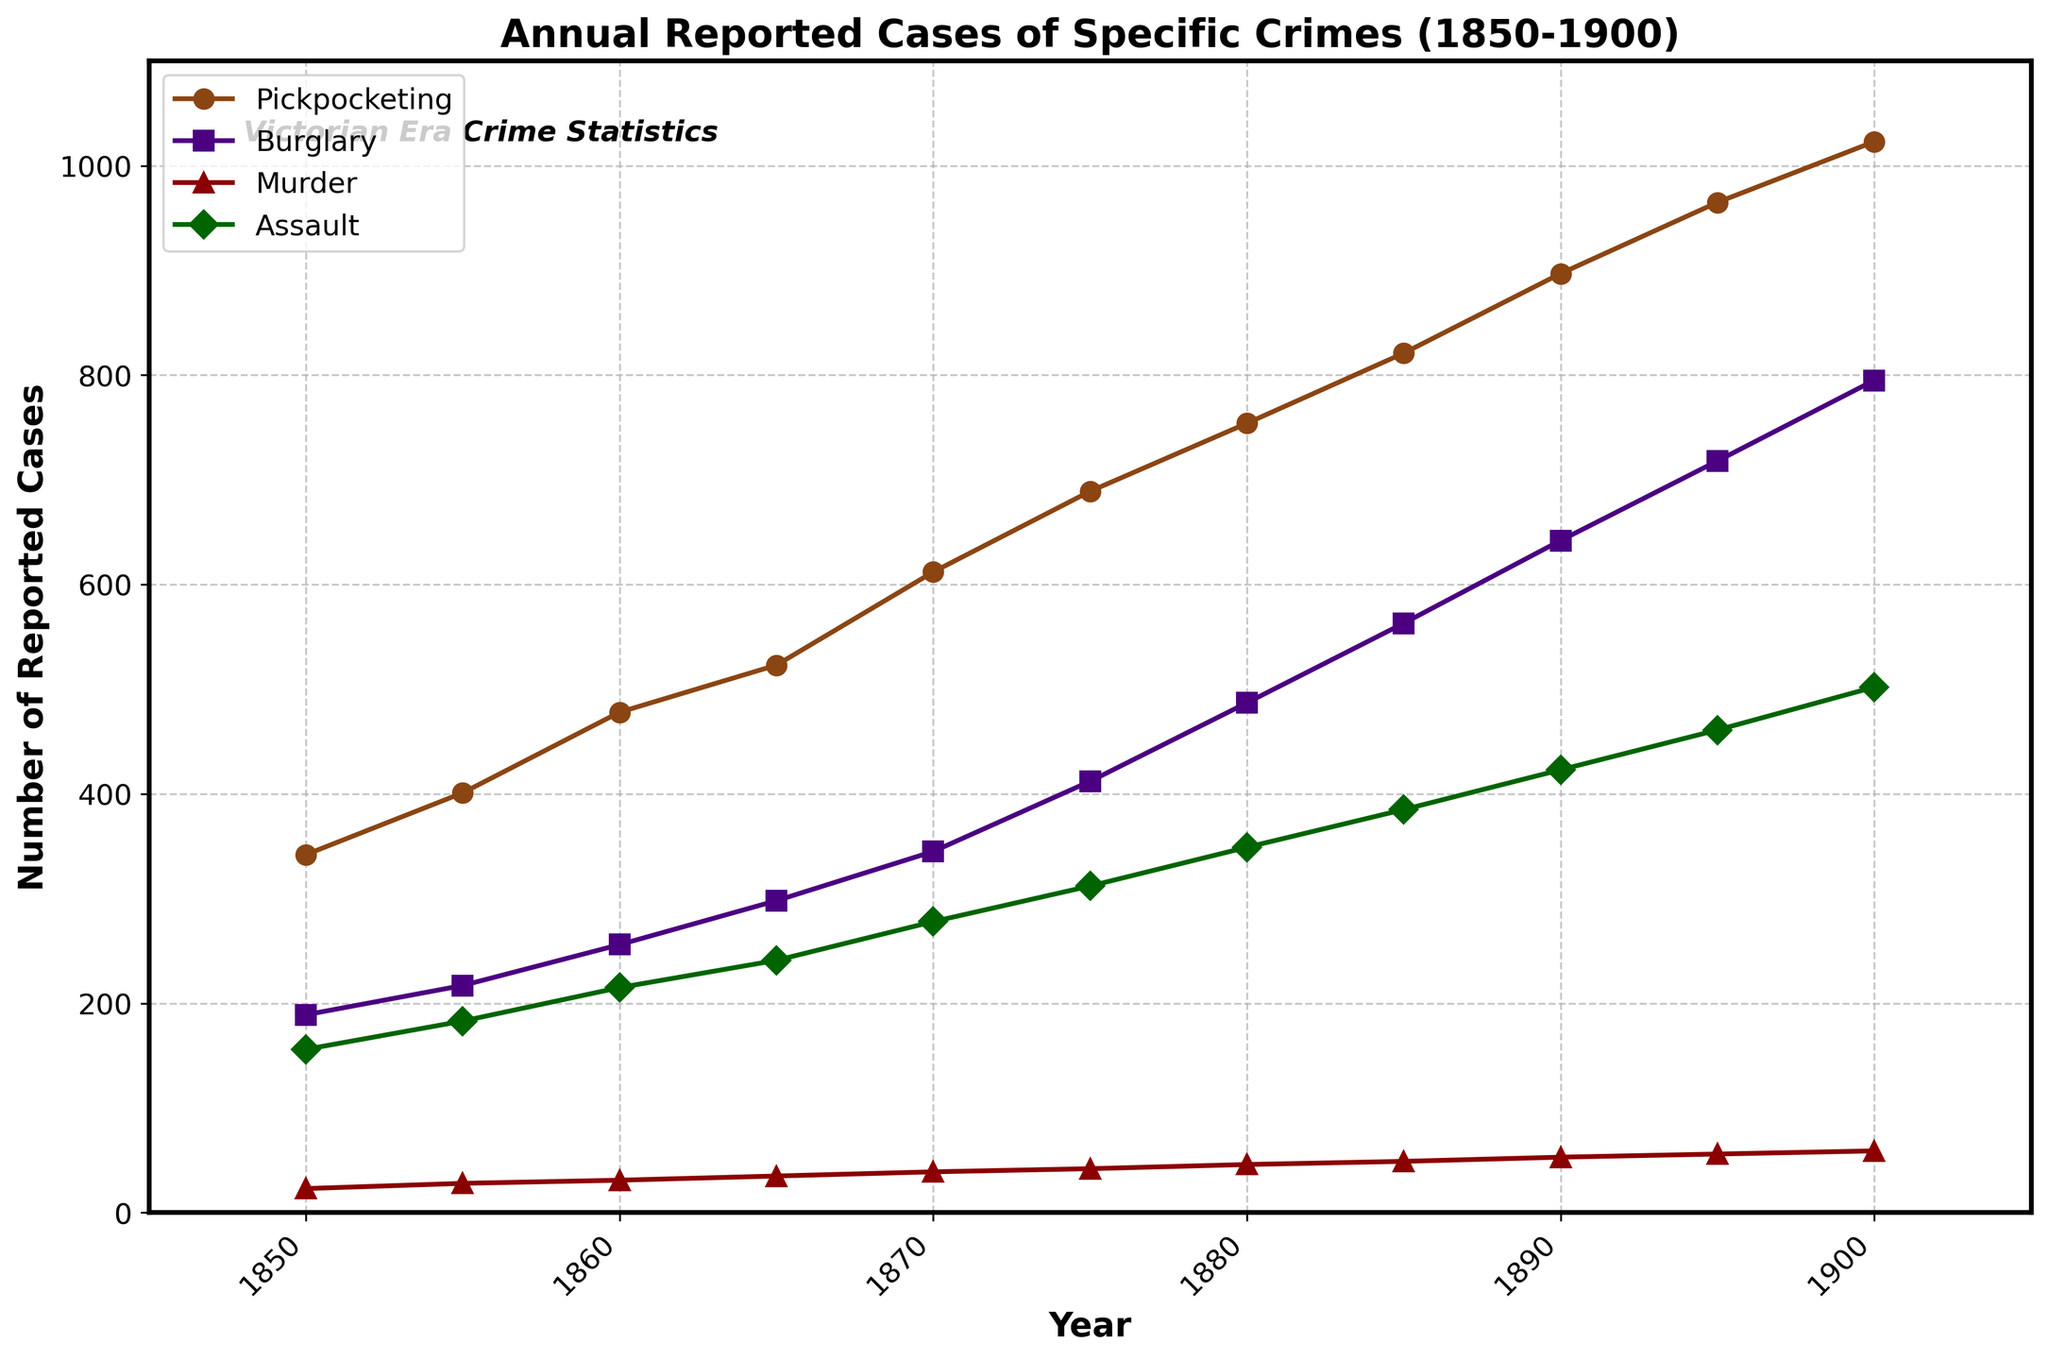What's the overall trend in the number of pickpocketing cases from 1850 to 1900? The number of pickpocketing cases shows a steady increase over the given period. In 1850, there were 342 reported cases, which rose to 1023 by 1900. This indicates a consistent upward trend in pickpocketing incidents in industrial cities during the Victorian era.
Answer: Steadily increasing Which crime had the highest number of reported cases in the year 1870? To answer this, look at the data points for each crime in the year 1870. Pickpocketing had 612 cases, burglary had 345, murder had 39, and assault had 278. The highest number of reported cases in 1870 was for pickpocketing.
Answer: Pickpocketing How did the number of reported murder cases change from 1850 to 1900? The number of reported murder cases increased over the given period. It started at 23 cases in 1850 and grew to 59 cases by 1900. This shows a gradual increase in murder cases over time.
Answer: Increased By how much did the number of assault cases increase from 1850 to 1900? To find the increase, subtract the number of assault cases in 1850 from the number in 1900. The values are 502 in 1900 and 156 in 1850. The increase is 502 - 156 = 346.
Answer: 346 Which crime showed the fastest growth in reported cases from 1850 to 1900? Comparing the differences, pickpocketing grew from 342 to 1023 (681 cases), burglary from 189 to 795 (606 cases), murder from 23 to 59 (36 cases), and assault from 156 to 502 (346 cases). Pickpocketing shows the fastest growth with an increase of 681 cases.
Answer: Pickpocketing In which decade did burglary see the highest increase in reported cases? Examine the decade-by-decade changes in burglary cases: 1850-1855 (28), 1855-1860 (39), 1860-1865 (42), 1865-1870 (47), 1870-1875 (67), 1875-1880 (75), 1880-1885 (76), 1885-1890 (79), 1890-1895 (76), 1895-1900 (77). The largest increase was between 1865 and 1870 with 47 cases.
Answer: 1865-1870 How do assault cases in 1850 compare visually to those in 1900 on the line chart? Visually, the number of assault cases in 1850 appears significantly lower compared to 1900. The marker for assault in 1850 is near the bottom of the chart, whereas it is much higher up in 1900, indicating a considerable increase.
Answer: Much lower in 1850 What is the difference between the number of pickpocketing cases and murder cases in 1900? In 1900, there were 1023 pickpocketing cases and 59 murder cases. Subtract the murder cases from the pickpocketing cases: 1023 - 59 = 964.
Answer: 964 Which crime had the least number of reported cases throughout the entire period? Reviewing the entire period, murder consistently had the lowest number of reported cases at each interval compared to other crimes.
Answer: Murder What's the average number of reported burglary cases in the years 1850, 1875, and 1900? To find the average, sum the burglary cases for the specified years and divide by the number of years. The sum is 189 (1850) + 412 (1875) + 795 (1900) = 1396. The average is 1396 / 3 = 465.3.
Answer: 465.3 